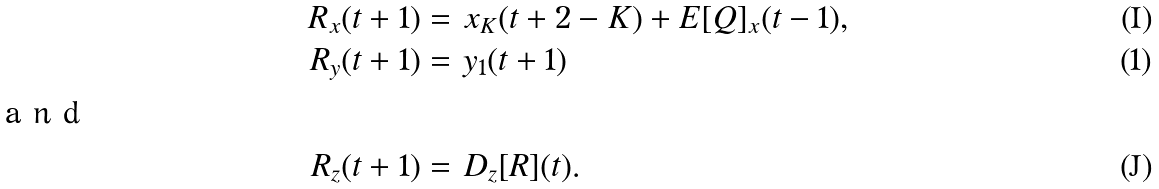<formula> <loc_0><loc_0><loc_500><loc_500>R _ { x } ( t + 1 ) = \ & x _ { K } ( t + 2 - K ) + E [ Q ] _ { x } ( t - 1 ) , \\ R _ { y } ( t + 1 ) = \ & y _ { 1 } ( t + 1 ) \intertext { a n d } R _ { z } ( t + 1 ) = \ & D _ { z } [ R ] ( t ) .</formula> 